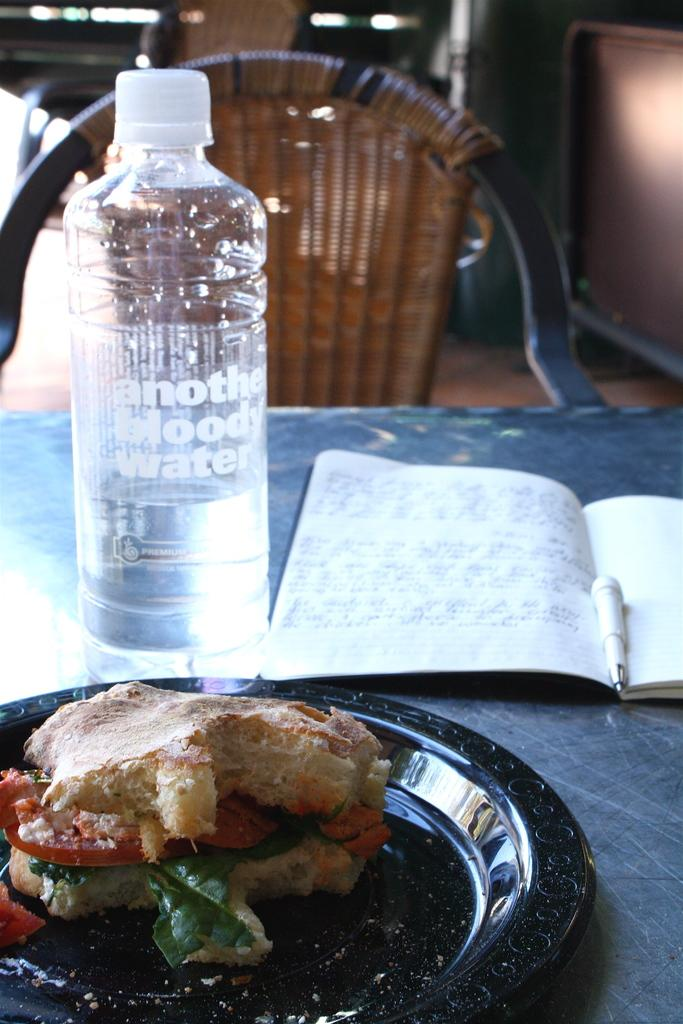What piece of furniture is present in the image? There is a table in the image. What object can be seen on the table? There is a book, a pen, a bottle, and a plate on the table. What is on the plate? There is food on the plate. Is there any seating visible in the image? Yes, there is a chair in the background of the image. What is the health status of the person who ate the food on the plate? The image does not provide any information about the health status of the person who ate the food on the plate. 